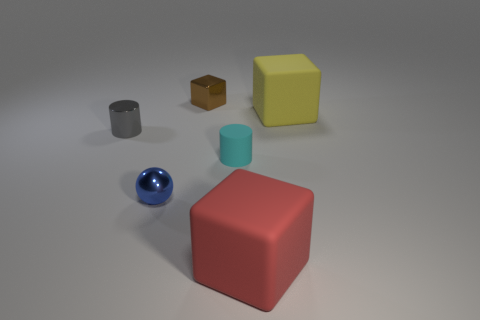What number of large gray rubber things are there?
Provide a succinct answer. 0. Are the ball and the yellow object made of the same material?
Offer a terse response. No. Are there more brown things that are right of the yellow block than big gray cubes?
Your answer should be compact. No. What number of things are either cyan rubber blocks or things behind the big yellow matte cube?
Offer a very short reply. 1. Are there more gray things behind the tiny block than blue balls behind the cyan cylinder?
Make the answer very short. No. What is the material of the object that is to the left of the small thing that is in front of the cylinder that is right of the brown shiny cube?
Keep it short and to the point. Metal. What is the shape of the tiny gray thing that is the same material as the small ball?
Keep it short and to the point. Cylinder. Are there any big rubber cubes to the right of the block in front of the small metal cylinder?
Make the answer very short. Yes. What is the size of the gray shiny cylinder?
Your answer should be compact. Small. What number of things are small purple cylinders or small metallic spheres?
Offer a terse response. 1. 